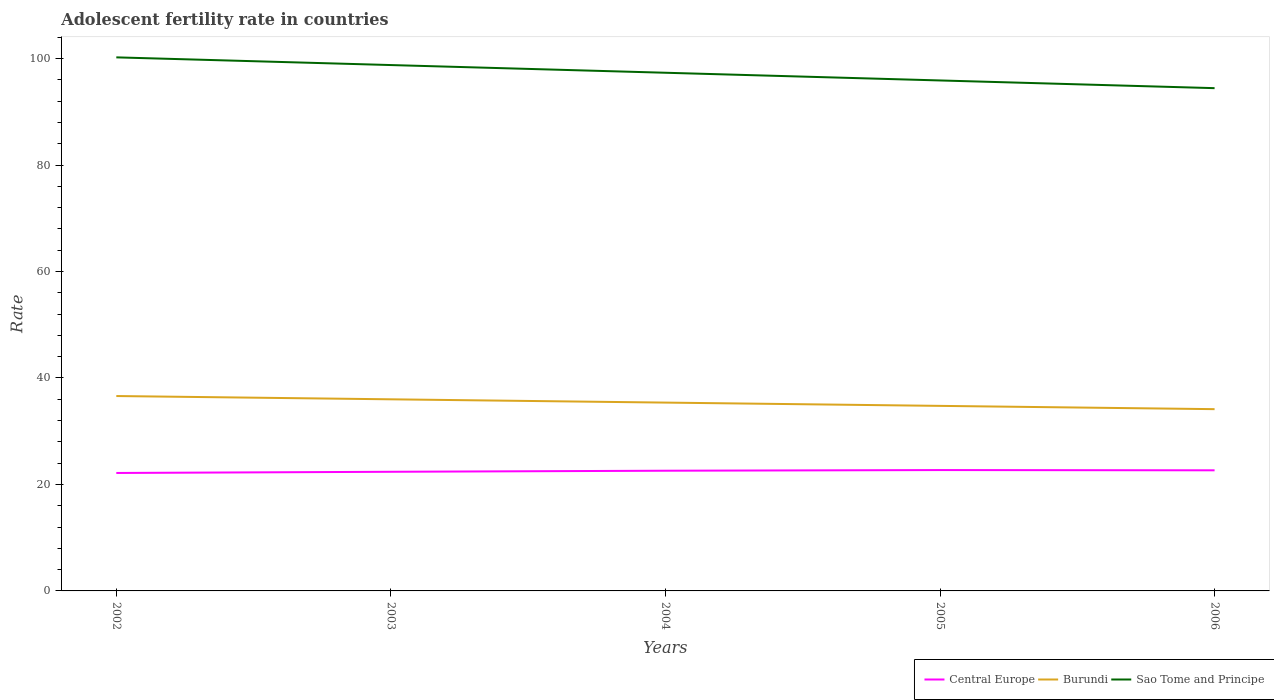Does the line corresponding to Burundi intersect with the line corresponding to Sao Tome and Principe?
Offer a very short reply. No. Across all years, what is the maximum adolescent fertility rate in Central Europe?
Your response must be concise. 22.16. What is the total adolescent fertility rate in Central Europe in the graph?
Your answer should be very brief. -0.12. What is the difference between the highest and the second highest adolescent fertility rate in Sao Tome and Principe?
Your answer should be compact. 5.78. Does the graph contain grids?
Make the answer very short. No. How many legend labels are there?
Provide a short and direct response. 3. How are the legend labels stacked?
Ensure brevity in your answer.  Horizontal. What is the title of the graph?
Provide a succinct answer. Adolescent fertility rate in countries. Does "San Marino" appear as one of the legend labels in the graph?
Provide a succinct answer. No. What is the label or title of the Y-axis?
Give a very brief answer. Rate. What is the Rate in Central Europe in 2002?
Make the answer very short. 22.16. What is the Rate in Burundi in 2002?
Give a very brief answer. 36.61. What is the Rate in Sao Tome and Principe in 2002?
Provide a succinct answer. 100.23. What is the Rate in Central Europe in 2003?
Offer a terse response. 22.38. What is the Rate of Burundi in 2003?
Keep it short and to the point. 36. What is the Rate in Sao Tome and Principe in 2003?
Provide a short and direct response. 98.79. What is the Rate in Central Europe in 2004?
Give a very brief answer. 22.58. What is the Rate in Burundi in 2004?
Make the answer very short. 35.38. What is the Rate of Sao Tome and Principe in 2004?
Offer a terse response. 97.34. What is the Rate of Central Europe in 2005?
Keep it short and to the point. 22.7. What is the Rate in Burundi in 2005?
Provide a succinct answer. 34.76. What is the Rate of Sao Tome and Principe in 2005?
Your answer should be very brief. 95.89. What is the Rate in Central Europe in 2006?
Offer a terse response. 22.66. What is the Rate in Burundi in 2006?
Your answer should be compact. 34.14. What is the Rate in Sao Tome and Principe in 2006?
Make the answer very short. 94.45. Across all years, what is the maximum Rate of Central Europe?
Give a very brief answer. 22.7. Across all years, what is the maximum Rate of Burundi?
Your answer should be compact. 36.61. Across all years, what is the maximum Rate in Sao Tome and Principe?
Keep it short and to the point. 100.23. Across all years, what is the minimum Rate of Central Europe?
Your answer should be compact. 22.16. Across all years, what is the minimum Rate of Burundi?
Offer a terse response. 34.14. Across all years, what is the minimum Rate in Sao Tome and Principe?
Provide a short and direct response. 94.45. What is the total Rate of Central Europe in the graph?
Your response must be concise. 112.48. What is the total Rate of Burundi in the graph?
Provide a short and direct response. 176.89. What is the total Rate of Sao Tome and Principe in the graph?
Offer a very short reply. 486.7. What is the difference between the Rate in Central Europe in 2002 and that in 2003?
Provide a short and direct response. -0.22. What is the difference between the Rate in Burundi in 2002 and that in 2003?
Your response must be concise. 0.62. What is the difference between the Rate of Sao Tome and Principe in 2002 and that in 2003?
Your answer should be compact. 1.45. What is the difference between the Rate in Central Europe in 2002 and that in 2004?
Ensure brevity in your answer.  -0.42. What is the difference between the Rate in Burundi in 2002 and that in 2004?
Offer a very short reply. 1.23. What is the difference between the Rate in Sao Tome and Principe in 2002 and that in 2004?
Make the answer very short. 2.89. What is the difference between the Rate in Central Europe in 2002 and that in 2005?
Keep it short and to the point. -0.55. What is the difference between the Rate in Burundi in 2002 and that in 2005?
Keep it short and to the point. 1.85. What is the difference between the Rate in Sao Tome and Principe in 2002 and that in 2005?
Your response must be concise. 4.34. What is the difference between the Rate in Central Europe in 2002 and that in 2006?
Offer a terse response. -0.5. What is the difference between the Rate in Burundi in 2002 and that in 2006?
Offer a very short reply. 2.47. What is the difference between the Rate of Sao Tome and Principe in 2002 and that in 2006?
Offer a very short reply. 5.78. What is the difference between the Rate of Central Europe in 2003 and that in 2004?
Provide a succinct answer. -0.2. What is the difference between the Rate of Burundi in 2003 and that in 2004?
Offer a terse response. 0.62. What is the difference between the Rate in Sao Tome and Principe in 2003 and that in 2004?
Your response must be concise. 1.45. What is the difference between the Rate in Central Europe in 2003 and that in 2005?
Provide a short and direct response. -0.32. What is the difference between the Rate of Burundi in 2003 and that in 2005?
Make the answer very short. 1.23. What is the difference between the Rate in Sao Tome and Principe in 2003 and that in 2005?
Your answer should be very brief. 2.89. What is the difference between the Rate of Central Europe in 2003 and that in 2006?
Your response must be concise. -0.28. What is the difference between the Rate of Burundi in 2003 and that in 2006?
Keep it short and to the point. 1.85. What is the difference between the Rate of Sao Tome and Principe in 2003 and that in 2006?
Ensure brevity in your answer.  4.34. What is the difference between the Rate in Central Europe in 2004 and that in 2005?
Offer a very short reply. -0.12. What is the difference between the Rate of Burundi in 2004 and that in 2005?
Offer a very short reply. 0.62. What is the difference between the Rate of Sao Tome and Principe in 2004 and that in 2005?
Make the answer very short. 1.45. What is the difference between the Rate of Central Europe in 2004 and that in 2006?
Offer a terse response. -0.08. What is the difference between the Rate in Burundi in 2004 and that in 2006?
Provide a succinct answer. 1.23. What is the difference between the Rate in Sao Tome and Principe in 2004 and that in 2006?
Provide a short and direct response. 2.89. What is the difference between the Rate in Central Europe in 2005 and that in 2006?
Ensure brevity in your answer.  0.05. What is the difference between the Rate of Burundi in 2005 and that in 2006?
Make the answer very short. 0.62. What is the difference between the Rate of Sao Tome and Principe in 2005 and that in 2006?
Keep it short and to the point. 1.45. What is the difference between the Rate of Central Europe in 2002 and the Rate of Burundi in 2003?
Your answer should be very brief. -13.84. What is the difference between the Rate in Central Europe in 2002 and the Rate in Sao Tome and Principe in 2003?
Provide a succinct answer. -76.63. What is the difference between the Rate of Burundi in 2002 and the Rate of Sao Tome and Principe in 2003?
Your response must be concise. -62.17. What is the difference between the Rate in Central Europe in 2002 and the Rate in Burundi in 2004?
Offer a terse response. -13.22. What is the difference between the Rate in Central Europe in 2002 and the Rate in Sao Tome and Principe in 2004?
Your answer should be compact. -75.18. What is the difference between the Rate of Burundi in 2002 and the Rate of Sao Tome and Principe in 2004?
Provide a short and direct response. -60.73. What is the difference between the Rate of Central Europe in 2002 and the Rate of Burundi in 2005?
Your answer should be very brief. -12.6. What is the difference between the Rate of Central Europe in 2002 and the Rate of Sao Tome and Principe in 2005?
Offer a terse response. -73.74. What is the difference between the Rate in Burundi in 2002 and the Rate in Sao Tome and Principe in 2005?
Your answer should be very brief. -59.28. What is the difference between the Rate in Central Europe in 2002 and the Rate in Burundi in 2006?
Provide a succinct answer. -11.99. What is the difference between the Rate in Central Europe in 2002 and the Rate in Sao Tome and Principe in 2006?
Your answer should be very brief. -72.29. What is the difference between the Rate in Burundi in 2002 and the Rate in Sao Tome and Principe in 2006?
Provide a succinct answer. -57.84. What is the difference between the Rate of Central Europe in 2003 and the Rate of Burundi in 2004?
Give a very brief answer. -13. What is the difference between the Rate in Central Europe in 2003 and the Rate in Sao Tome and Principe in 2004?
Offer a very short reply. -74.96. What is the difference between the Rate of Burundi in 2003 and the Rate of Sao Tome and Principe in 2004?
Provide a short and direct response. -61.34. What is the difference between the Rate in Central Europe in 2003 and the Rate in Burundi in 2005?
Provide a short and direct response. -12.38. What is the difference between the Rate of Central Europe in 2003 and the Rate of Sao Tome and Principe in 2005?
Offer a very short reply. -73.51. What is the difference between the Rate of Burundi in 2003 and the Rate of Sao Tome and Principe in 2005?
Make the answer very short. -59.9. What is the difference between the Rate of Central Europe in 2003 and the Rate of Burundi in 2006?
Your answer should be very brief. -11.76. What is the difference between the Rate of Central Europe in 2003 and the Rate of Sao Tome and Principe in 2006?
Make the answer very short. -72.07. What is the difference between the Rate in Burundi in 2003 and the Rate in Sao Tome and Principe in 2006?
Keep it short and to the point. -58.45. What is the difference between the Rate in Central Europe in 2004 and the Rate in Burundi in 2005?
Ensure brevity in your answer.  -12.18. What is the difference between the Rate in Central Europe in 2004 and the Rate in Sao Tome and Principe in 2005?
Your answer should be compact. -73.31. What is the difference between the Rate of Burundi in 2004 and the Rate of Sao Tome and Principe in 2005?
Offer a terse response. -60.52. What is the difference between the Rate in Central Europe in 2004 and the Rate in Burundi in 2006?
Your answer should be compact. -11.56. What is the difference between the Rate in Central Europe in 2004 and the Rate in Sao Tome and Principe in 2006?
Give a very brief answer. -71.87. What is the difference between the Rate of Burundi in 2004 and the Rate of Sao Tome and Principe in 2006?
Your answer should be very brief. -59.07. What is the difference between the Rate in Central Europe in 2005 and the Rate in Burundi in 2006?
Your answer should be compact. -11.44. What is the difference between the Rate in Central Europe in 2005 and the Rate in Sao Tome and Principe in 2006?
Make the answer very short. -71.74. What is the difference between the Rate of Burundi in 2005 and the Rate of Sao Tome and Principe in 2006?
Provide a short and direct response. -59.69. What is the average Rate of Central Europe per year?
Offer a very short reply. 22.5. What is the average Rate of Burundi per year?
Your answer should be very brief. 35.38. What is the average Rate in Sao Tome and Principe per year?
Offer a terse response. 97.34. In the year 2002, what is the difference between the Rate of Central Europe and Rate of Burundi?
Provide a short and direct response. -14.46. In the year 2002, what is the difference between the Rate in Central Europe and Rate in Sao Tome and Principe?
Your response must be concise. -78.08. In the year 2002, what is the difference between the Rate of Burundi and Rate of Sao Tome and Principe?
Make the answer very short. -63.62. In the year 2003, what is the difference between the Rate of Central Europe and Rate of Burundi?
Provide a short and direct response. -13.62. In the year 2003, what is the difference between the Rate in Central Europe and Rate in Sao Tome and Principe?
Give a very brief answer. -76.41. In the year 2003, what is the difference between the Rate in Burundi and Rate in Sao Tome and Principe?
Provide a short and direct response. -62.79. In the year 2004, what is the difference between the Rate of Central Europe and Rate of Burundi?
Keep it short and to the point. -12.8. In the year 2004, what is the difference between the Rate of Central Europe and Rate of Sao Tome and Principe?
Offer a very short reply. -74.76. In the year 2004, what is the difference between the Rate of Burundi and Rate of Sao Tome and Principe?
Your answer should be very brief. -61.96. In the year 2005, what is the difference between the Rate in Central Europe and Rate in Burundi?
Offer a terse response. -12.06. In the year 2005, what is the difference between the Rate of Central Europe and Rate of Sao Tome and Principe?
Provide a succinct answer. -73.19. In the year 2005, what is the difference between the Rate of Burundi and Rate of Sao Tome and Principe?
Offer a very short reply. -61.13. In the year 2006, what is the difference between the Rate in Central Europe and Rate in Burundi?
Ensure brevity in your answer.  -11.49. In the year 2006, what is the difference between the Rate of Central Europe and Rate of Sao Tome and Principe?
Provide a short and direct response. -71.79. In the year 2006, what is the difference between the Rate in Burundi and Rate in Sao Tome and Principe?
Give a very brief answer. -60.3. What is the ratio of the Rate in Burundi in 2002 to that in 2003?
Make the answer very short. 1.02. What is the ratio of the Rate in Sao Tome and Principe in 2002 to that in 2003?
Offer a very short reply. 1.01. What is the ratio of the Rate of Central Europe in 2002 to that in 2004?
Your answer should be very brief. 0.98. What is the ratio of the Rate of Burundi in 2002 to that in 2004?
Offer a very short reply. 1.03. What is the ratio of the Rate of Sao Tome and Principe in 2002 to that in 2004?
Ensure brevity in your answer.  1.03. What is the ratio of the Rate of Central Europe in 2002 to that in 2005?
Keep it short and to the point. 0.98. What is the ratio of the Rate in Burundi in 2002 to that in 2005?
Make the answer very short. 1.05. What is the ratio of the Rate in Sao Tome and Principe in 2002 to that in 2005?
Make the answer very short. 1.05. What is the ratio of the Rate in Central Europe in 2002 to that in 2006?
Give a very brief answer. 0.98. What is the ratio of the Rate of Burundi in 2002 to that in 2006?
Your response must be concise. 1.07. What is the ratio of the Rate of Sao Tome and Principe in 2002 to that in 2006?
Your answer should be very brief. 1.06. What is the ratio of the Rate in Central Europe in 2003 to that in 2004?
Give a very brief answer. 0.99. What is the ratio of the Rate of Burundi in 2003 to that in 2004?
Your answer should be compact. 1.02. What is the ratio of the Rate of Sao Tome and Principe in 2003 to that in 2004?
Provide a short and direct response. 1.01. What is the ratio of the Rate of Central Europe in 2003 to that in 2005?
Provide a succinct answer. 0.99. What is the ratio of the Rate of Burundi in 2003 to that in 2005?
Offer a very short reply. 1.04. What is the ratio of the Rate of Sao Tome and Principe in 2003 to that in 2005?
Your answer should be compact. 1.03. What is the ratio of the Rate of Burundi in 2003 to that in 2006?
Give a very brief answer. 1.05. What is the ratio of the Rate in Sao Tome and Principe in 2003 to that in 2006?
Ensure brevity in your answer.  1.05. What is the ratio of the Rate in Central Europe in 2004 to that in 2005?
Offer a very short reply. 0.99. What is the ratio of the Rate in Burundi in 2004 to that in 2005?
Your answer should be very brief. 1.02. What is the ratio of the Rate in Sao Tome and Principe in 2004 to that in 2005?
Keep it short and to the point. 1.02. What is the ratio of the Rate in Central Europe in 2004 to that in 2006?
Your answer should be very brief. 1. What is the ratio of the Rate in Burundi in 2004 to that in 2006?
Offer a very short reply. 1.04. What is the ratio of the Rate in Sao Tome and Principe in 2004 to that in 2006?
Provide a short and direct response. 1.03. What is the ratio of the Rate of Central Europe in 2005 to that in 2006?
Offer a terse response. 1. What is the ratio of the Rate of Burundi in 2005 to that in 2006?
Make the answer very short. 1.02. What is the ratio of the Rate in Sao Tome and Principe in 2005 to that in 2006?
Make the answer very short. 1.02. What is the difference between the highest and the second highest Rate in Central Europe?
Your response must be concise. 0.05. What is the difference between the highest and the second highest Rate of Burundi?
Ensure brevity in your answer.  0.62. What is the difference between the highest and the second highest Rate in Sao Tome and Principe?
Your answer should be compact. 1.45. What is the difference between the highest and the lowest Rate in Central Europe?
Offer a very short reply. 0.55. What is the difference between the highest and the lowest Rate of Burundi?
Offer a very short reply. 2.47. What is the difference between the highest and the lowest Rate of Sao Tome and Principe?
Offer a very short reply. 5.78. 